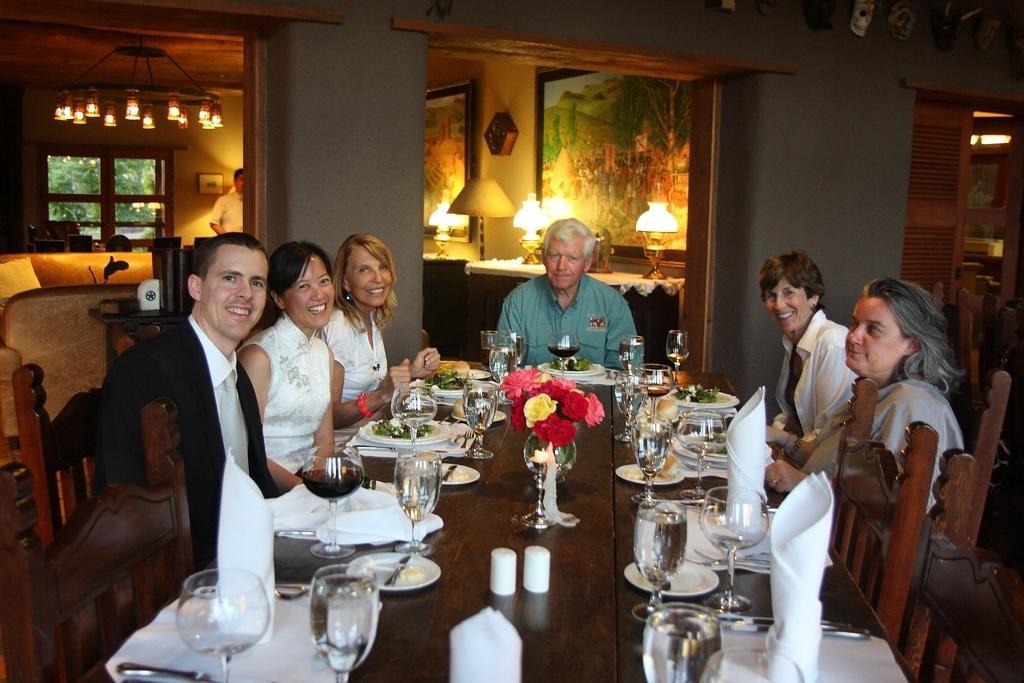Describe this image in one or two sentences. In this picture we can see some persons are sitting on the chairs. This is the table. On the table there are some glasses, plates, and there is a flower vase. On the background we can see the wall. And these are the lights. And there is a frame. 